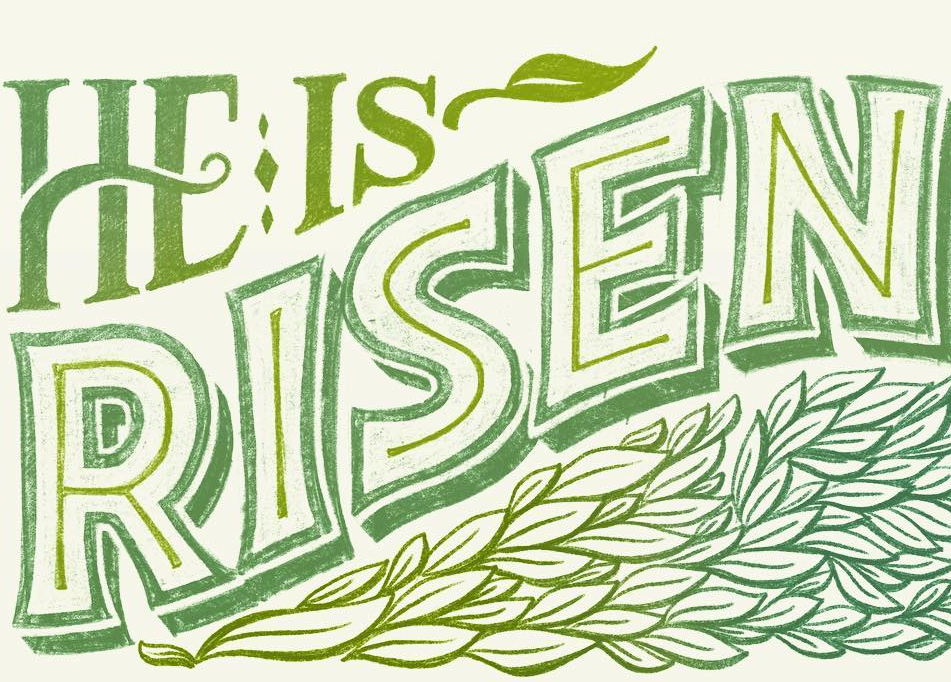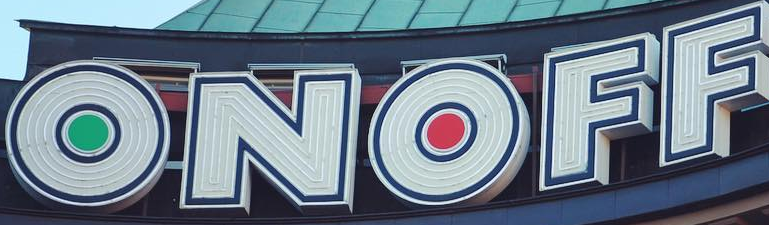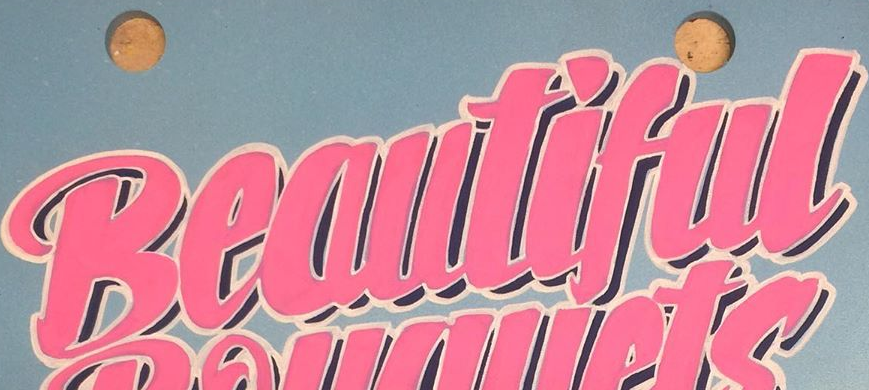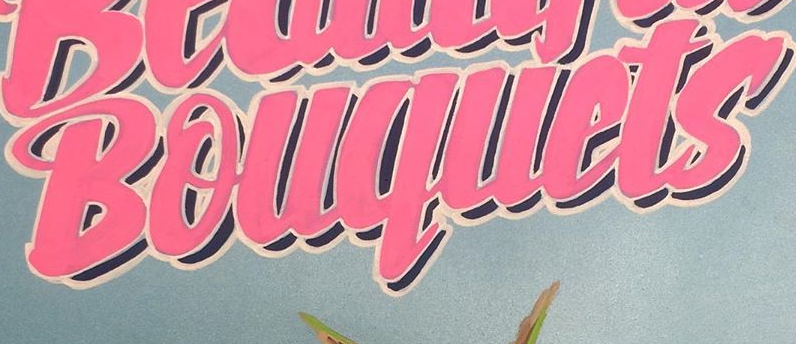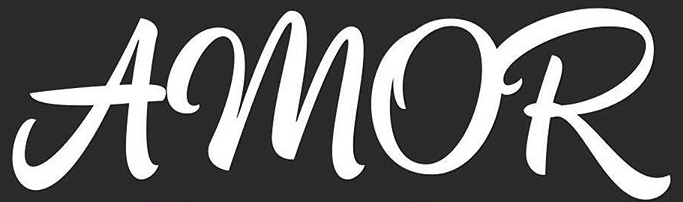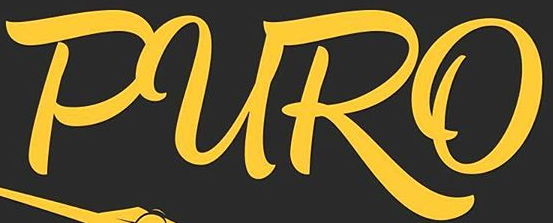Read the text from these images in sequence, separated by a semicolon. RISEN; ONOFF; Beautiful; Bouquets; AMOR; PURO 